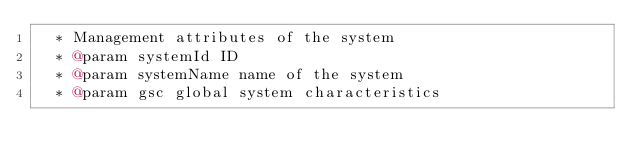Convert code to text. <code><loc_0><loc_0><loc_500><loc_500><_Scala_>  * Management attributes of the system
  * @param systemId ID
  * @param systemName name of the system
  * @param gsc global system characteristics</code> 